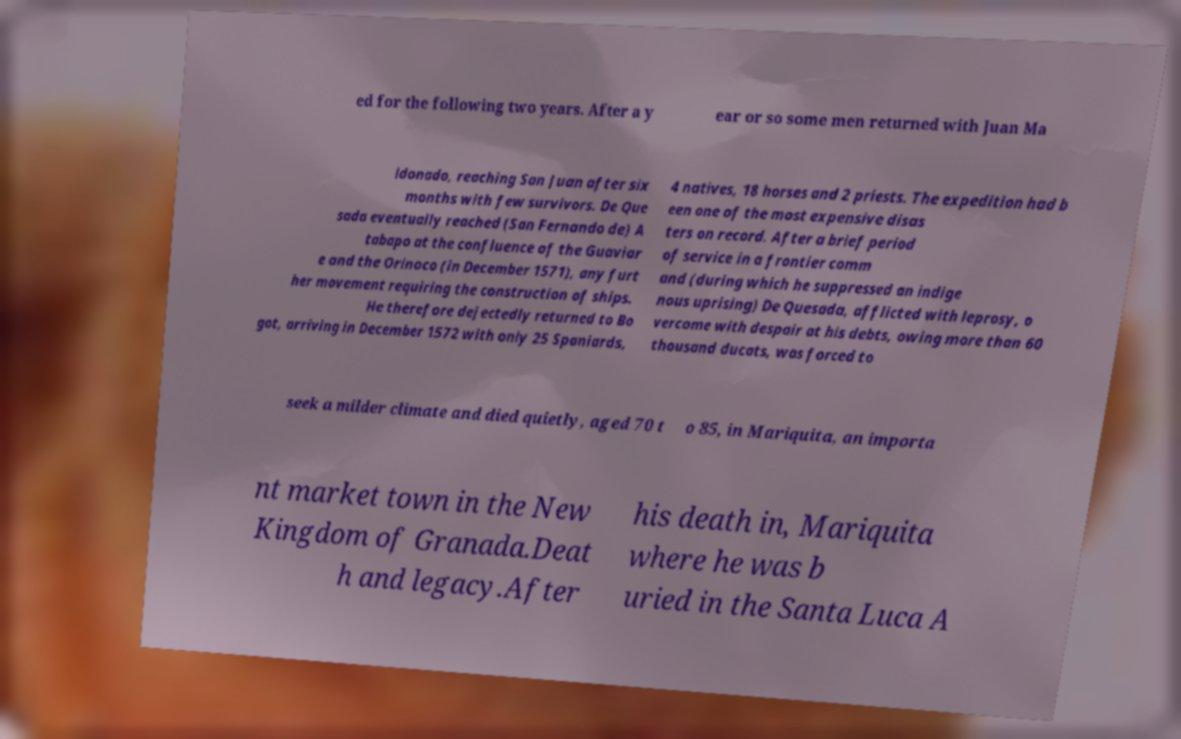I need the written content from this picture converted into text. Can you do that? ed for the following two years. After a y ear or so some men returned with Juan Ma ldonado, reaching San Juan after six months with few survivors. De Que sada eventually reached (San Fernando de) A tabapo at the confluence of the Guaviar e and the Orinoco (in December 1571), any furt her movement requiring the construction of ships. He therefore dejectedly returned to Bo got, arriving in December 1572 with only 25 Spaniards, 4 natives, 18 horses and 2 priests. The expedition had b een one of the most expensive disas ters on record. After a brief period of service in a frontier comm and (during which he suppressed an indige nous uprising) De Quesada, afflicted with leprosy, o vercome with despair at his debts, owing more than 60 thousand ducats, was forced to seek a milder climate and died quietly, aged 70 t o 85, in Mariquita, an importa nt market town in the New Kingdom of Granada.Deat h and legacy.After his death in, Mariquita where he was b uried in the Santa Luca A 